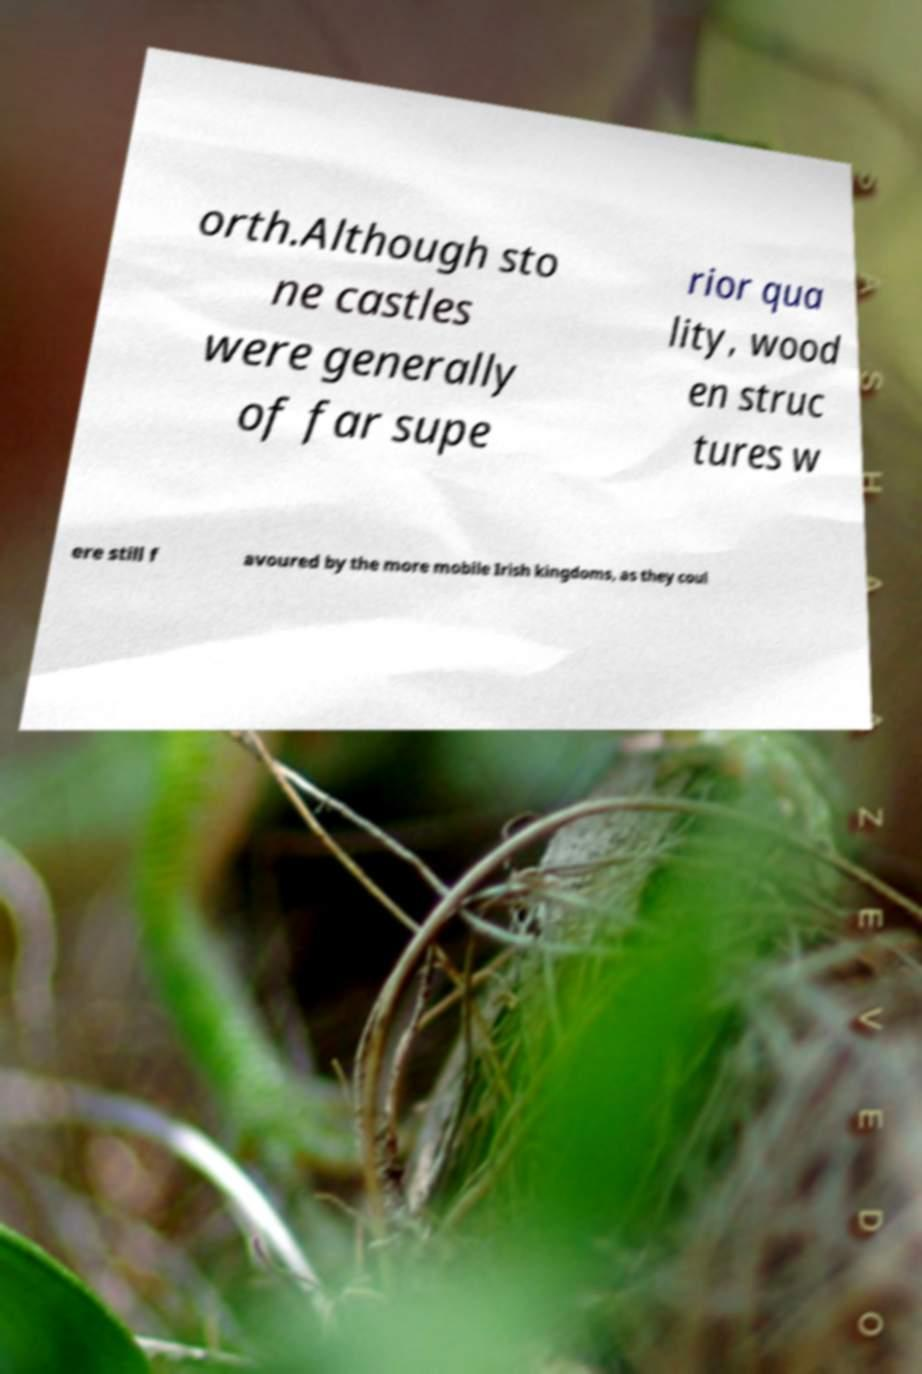I need the written content from this picture converted into text. Can you do that? orth.Although sto ne castles were generally of far supe rior qua lity, wood en struc tures w ere still f avoured by the more mobile Irish kingdoms, as they coul 